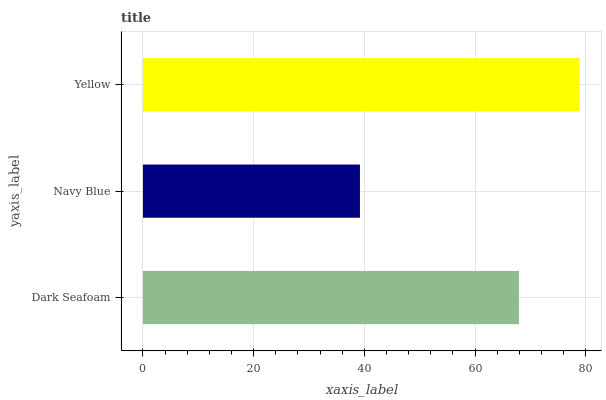Is Navy Blue the minimum?
Answer yes or no. Yes. Is Yellow the maximum?
Answer yes or no. Yes. Is Yellow the minimum?
Answer yes or no. No. Is Navy Blue the maximum?
Answer yes or no. No. Is Yellow greater than Navy Blue?
Answer yes or no. Yes. Is Navy Blue less than Yellow?
Answer yes or no. Yes. Is Navy Blue greater than Yellow?
Answer yes or no. No. Is Yellow less than Navy Blue?
Answer yes or no. No. Is Dark Seafoam the high median?
Answer yes or no. Yes. Is Dark Seafoam the low median?
Answer yes or no. Yes. Is Yellow the high median?
Answer yes or no. No. Is Navy Blue the low median?
Answer yes or no. No. 